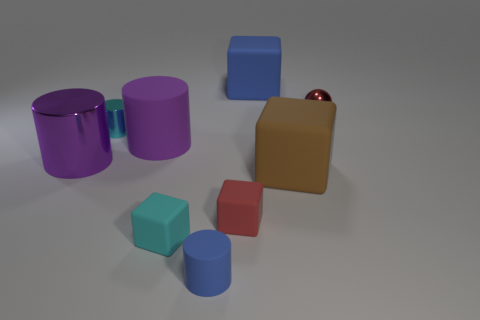Do the purple shiny thing and the blue matte object that is in front of the red metallic thing have the same shape?
Make the answer very short. Yes. Are there any large blue balls that have the same material as the big brown thing?
Your answer should be compact. No. There is a cube to the left of the red object left of the tiny metal sphere; is there a red object to the left of it?
Keep it short and to the point. No. What number of other things are there of the same shape as the big metal thing?
Offer a very short reply. 3. The tiny cylinder that is in front of the rubber block right of the big block that is behind the purple rubber cylinder is what color?
Offer a terse response. Blue. How many yellow matte cubes are there?
Provide a succinct answer. 0. How many tiny things are either cyan cylinders or red matte spheres?
Your response must be concise. 1. The purple rubber object that is the same size as the purple metal object is what shape?
Offer a very short reply. Cylinder. The large purple thing that is to the right of the small metallic object that is on the left side of the purple rubber thing is made of what material?
Your answer should be very brief. Rubber. Is the cyan rubber object the same size as the cyan shiny thing?
Provide a succinct answer. Yes. 